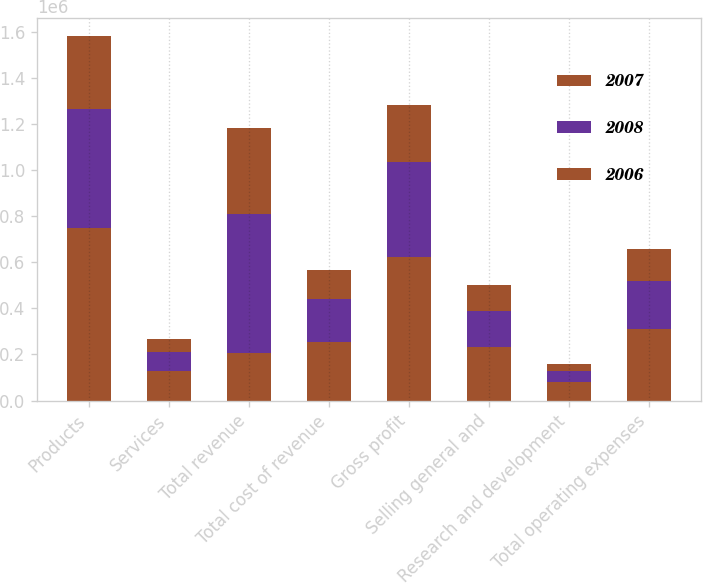Convert chart. <chart><loc_0><loc_0><loc_500><loc_500><stacked_bar_chart><ecel><fcel>Products<fcel>Services<fcel>Total revenue<fcel>Total cost of revenue<fcel>Gross profit<fcel>Selling general and<fcel>Research and development<fcel>Total operating expenses<nl><fcel>2007<fcel>748325<fcel>126594<fcel>207544<fcel>254142<fcel>620777<fcel>230570<fcel>79372<fcel>309942<nl><fcel>2008<fcel>516089<fcel>84739<fcel>600828<fcel>186542<fcel>414286<fcel>158685<fcel>48859<fcel>207544<nl><fcel>2006<fcel>317599<fcel>55083<fcel>372682<fcel>124846<fcel>247836<fcel>110703<fcel>29778<fcel>140481<nl></chart> 